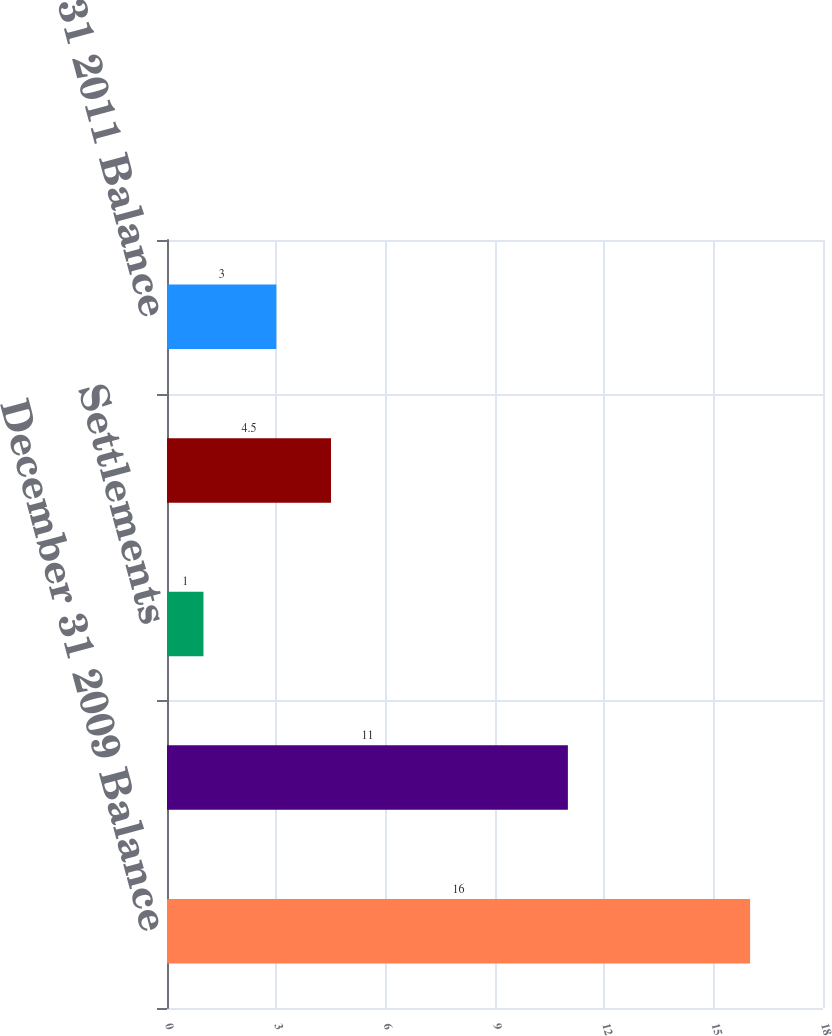<chart> <loc_0><loc_0><loc_500><loc_500><bar_chart><fcel>December 31 2009 Balance<fcel>Unrealized gain (loss)<fcel>Settlements<fcel>December 31 2010 Balance<fcel>December 31 2011 Balance<nl><fcel>16<fcel>11<fcel>1<fcel>4.5<fcel>3<nl></chart> 